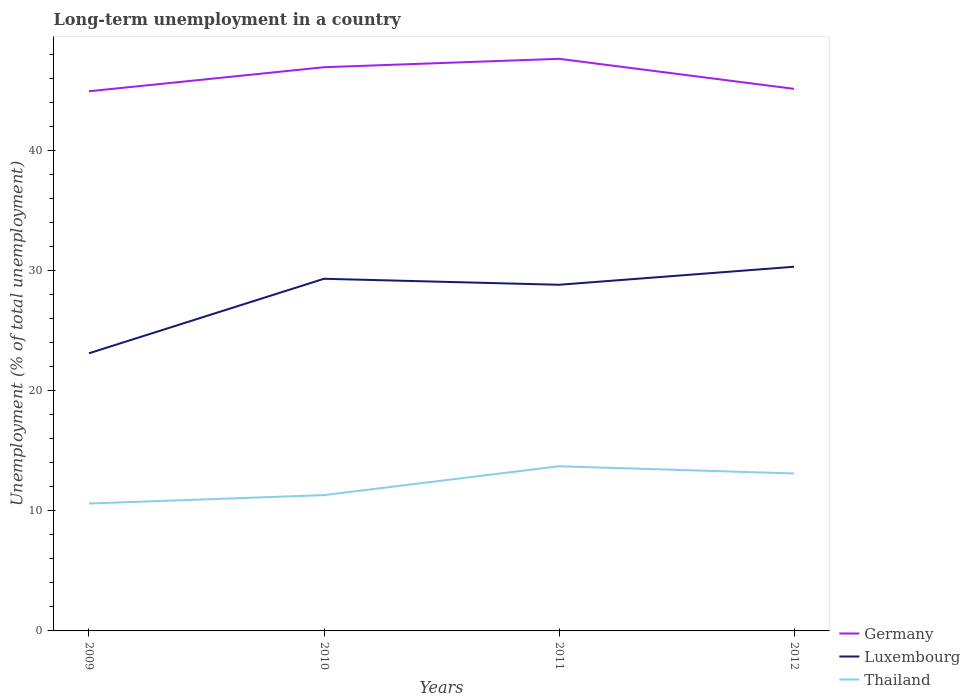How many different coloured lines are there?
Offer a terse response. 3. Across all years, what is the maximum percentage of long-term unemployed population in Germany?
Keep it short and to the point. 44.9. In which year was the percentage of long-term unemployed population in Luxembourg maximum?
Keep it short and to the point. 2009. What is the total percentage of long-term unemployed population in Luxembourg in the graph?
Make the answer very short. -5.7. What is the difference between the highest and the second highest percentage of long-term unemployed population in Germany?
Your answer should be compact. 2.7. What is the difference between the highest and the lowest percentage of long-term unemployed population in Thailand?
Make the answer very short. 2. How many years are there in the graph?
Your answer should be very brief. 4. What is the difference between two consecutive major ticks on the Y-axis?
Provide a succinct answer. 10. Are the values on the major ticks of Y-axis written in scientific E-notation?
Offer a terse response. No. Where does the legend appear in the graph?
Your answer should be very brief. Bottom right. What is the title of the graph?
Offer a terse response. Long-term unemployment in a country. Does "Kosovo" appear as one of the legend labels in the graph?
Keep it short and to the point. No. What is the label or title of the Y-axis?
Offer a terse response. Unemployment (% of total unemployment). What is the Unemployment (% of total unemployment) in Germany in 2009?
Your answer should be compact. 44.9. What is the Unemployment (% of total unemployment) in Luxembourg in 2009?
Ensure brevity in your answer.  23.1. What is the Unemployment (% of total unemployment) of Thailand in 2009?
Ensure brevity in your answer.  10.6. What is the Unemployment (% of total unemployment) of Germany in 2010?
Offer a terse response. 46.9. What is the Unemployment (% of total unemployment) in Luxembourg in 2010?
Provide a short and direct response. 29.3. What is the Unemployment (% of total unemployment) in Thailand in 2010?
Your response must be concise. 11.3. What is the Unemployment (% of total unemployment) in Germany in 2011?
Your answer should be very brief. 47.6. What is the Unemployment (% of total unemployment) in Luxembourg in 2011?
Provide a succinct answer. 28.8. What is the Unemployment (% of total unemployment) in Thailand in 2011?
Give a very brief answer. 13.7. What is the Unemployment (% of total unemployment) of Germany in 2012?
Provide a succinct answer. 45.1. What is the Unemployment (% of total unemployment) in Luxembourg in 2012?
Give a very brief answer. 30.3. What is the Unemployment (% of total unemployment) of Thailand in 2012?
Give a very brief answer. 13.1. Across all years, what is the maximum Unemployment (% of total unemployment) in Germany?
Provide a succinct answer. 47.6. Across all years, what is the maximum Unemployment (% of total unemployment) of Luxembourg?
Offer a very short reply. 30.3. Across all years, what is the maximum Unemployment (% of total unemployment) in Thailand?
Your answer should be compact. 13.7. Across all years, what is the minimum Unemployment (% of total unemployment) in Germany?
Offer a very short reply. 44.9. Across all years, what is the minimum Unemployment (% of total unemployment) in Luxembourg?
Provide a succinct answer. 23.1. Across all years, what is the minimum Unemployment (% of total unemployment) of Thailand?
Offer a very short reply. 10.6. What is the total Unemployment (% of total unemployment) in Germany in the graph?
Offer a terse response. 184.5. What is the total Unemployment (% of total unemployment) in Luxembourg in the graph?
Ensure brevity in your answer.  111.5. What is the total Unemployment (% of total unemployment) in Thailand in the graph?
Offer a very short reply. 48.7. What is the difference between the Unemployment (% of total unemployment) of Thailand in 2009 and that in 2010?
Give a very brief answer. -0.7. What is the difference between the Unemployment (% of total unemployment) in Germany in 2010 and that in 2012?
Your answer should be compact. 1.8. What is the difference between the Unemployment (% of total unemployment) of Luxembourg in 2010 and that in 2012?
Provide a short and direct response. -1. What is the difference between the Unemployment (% of total unemployment) of Thailand in 2010 and that in 2012?
Keep it short and to the point. -1.8. What is the difference between the Unemployment (% of total unemployment) in Thailand in 2011 and that in 2012?
Make the answer very short. 0.6. What is the difference between the Unemployment (% of total unemployment) in Germany in 2009 and the Unemployment (% of total unemployment) in Luxembourg in 2010?
Give a very brief answer. 15.6. What is the difference between the Unemployment (% of total unemployment) of Germany in 2009 and the Unemployment (% of total unemployment) of Thailand in 2010?
Your answer should be compact. 33.6. What is the difference between the Unemployment (% of total unemployment) in Germany in 2009 and the Unemployment (% of total unemployment) in Thailand in 2011?
Provide a succinct answer. 31.2. What is the difference between the Unemployment (% of total unemployment) in Germany in 2009 and the Unemployment (% of total unemployment) in Thailand in 2012?
Provide a short and direct response. 31.8. What is the difference between the Unemployment (% of total unemployment) in Germany in 2010 and the Unemployment (% of total unemployment) in Luxembourg in 2011?
Your answer should be very brief. 18.1. What is the difference between the Unemployment (% of total unemployment) of Germany in 2010 and the Unemployment (% of total unemployment) of Thailand in 2011?
Your answer should be very brief. 33.2. What is the difference between the Unemployment (% of total unemployment) of Luxembourg in 2010 and the Unemployment (% of total unemployment) of Thailand in 2011?
Ensure brevity in your answer.  15.6. What is the difference between the Unemployment (% of total unemployment) of Germany in 2010 and the Unemployment (% of total unemployment) of Luxembourg in 2012?
Your answer should be very brief. 16.6. What is the difference between the Unemployment (% of total unemployment) of Germany in 2010 and the Unemployment (% of total unemployment) of Thailand in 2012?
Provide a succinct answer. 33.8. What is the difference between the Unemployment (% of total unemployment) in Luxembourg in 2010 and the Unemployment (% of total unemployment) in Thailand in 2012?
Your answer should be compact. 16.2. What is the difference between the Unemployment (% of total unemployment) of Germany in 2011 and the Unemployment (% of total unemployment) of Luxembourg in 2012?
Offer a very short reply. 17.3. What is the difference between the Unemployment (% of total unemployment) of Germany in 2011 and the Unemployment (% of total unemployment) of Thailand in 2012?
Your answer should be compact. 34.5. What is the difference between the Unemployment (% of total unemployment) in Luxembourg in 2011 and the Unemployment (% of total unemployment) in Thailand in 2012?
Provide a short and direct response. 15.7. What is the average Unemployment (% of total unemployment) in Germany per year?
Offer a terse response. 46.12. What is the average Unemployment (% of total unemployment) in Luxembourg per year?
Keep it short and to the point. 27.88. What is the average Unemployment (% of total unemployment) of Thailand per year?
Offer a very short reply. 12.18. In the year 2009, what is the difference between the Unemployment (% of total unemployment) of Germany and Unemployment (% of total unemployment) of Luxembourg?
Give a very brief answer. 21.8. In the year 2009, what is the difference between the Unemployment (% of total unemployment) in Germany and Unemployment (% of total unemployment) in Thailand?
Provide a short and direct response. 34.3. In the year 2010, what is the difference between the Unemployment (% of total unemployment) in Germany and Unemployment (% of total unemployment) in Thailand?
Provide a succinct answer. 35.6. In the year 2011, what is the difference between the Unemployment (% of total unemployment) of Germany and Unemployment (% of total unemployment) of Thailand?
Your response must be concise. 33.9. In the year 2012, what is the difference between the Unemployment (% of total unemployment) in Luxembourg and Unemployment (% of total unemployment) in Thailand?
Your answer should be compact. 17.2. What is the ratio of the Unemployment (% of total unemployment) in Germany in 2009 to that in 2010?
Give a very brief answer. 0.96. What is the ratio of the Unemployment (% of total unemployment) of Luxembourg in 2009 to that in 2010?
Give a very brief answer. 0.79. What is the ratio of the Unemployment (% of total unemployment) in Thailand in 2009 to that in 2010?
Provide a short and direct response. 0.94. What is the ratio of the Unemployment (% of total unemployment) of Germany in 2009 to that in 2011?
Make the answer very short. 0.94. What is the ratio of the Unemployment (% of total unemployment) of Luxembourg in 2009 to that in 2011?
Keep it short and to the point. 0.8. What is the ratio of the Unemployment (% of total unemployment) in Thailand in 2009 to that in 2011?
Provide a succinct answer. 0.77. What is the ratio of the Unemployment (% of total unemployment) in Luxembourg in 2009 to that in 2012?
Provide a short and direct response. 0.76. What is the ratio of the Unemployment (% of total unemployment) of Thailand in 2009 to that in 2012?
Keep it short and to the point. 0.81. What is the ratio of the Unemployment (% of total unemployment) of Germany in 2010 to that in 2011?
Keep it short and to the point. 0.99. What is the ratio of the Unemployment (% of total unemployment) in Luxembourg in 2010 to that in 2011?
Give a very brief answer. 1.02. What is the ratio of the Unemployment (% of total unemployment) in Thailand in 2010 to that in 2011?
Your response must be concise. 0.82. What is the ratio of the Unemployment (% of total unemployment) in Germany in 2010 to that in 2012?
Your response must be concise. 1.04. What is the ratio of the Unemployment (% of total unemployment) in Thailand in 2010 to that in 2012?
Make the answer very short. 0.86. What is the ratio of the Unemployment (% of total unemployment) of Germany in 2011 to that in 2012?
Your response must be concise. 1.06. What is the ratio of the Unemployment (% of total unemployment) of Luxembourg in 2011 to that in 2012?
Provide a succinct answer. 0.95. What is the ratio of the Unemployment (% of total unemployment) of Thailand in 2011 to that in 2012?
Keep it short and to the point. 1.05. What is the difference between the highest and the second highest Unemployment (% of total unemployment) in Germany?
Your answer should be compact. 0.7. What is the difference between the highest and the lowest Unemployment (% of total unemployment) of Germany?
Ensure brevity in your answer.  2.7. What is the difference between the highest and the lowest Unemployment (% of total unemployment) of Luxembourg?
Your answer should be very brief. 7.2. What is the difference between the highest and the lowest Unemployment (% of total unemployment) of Thailand?
Your response must be concise. 3.1. 